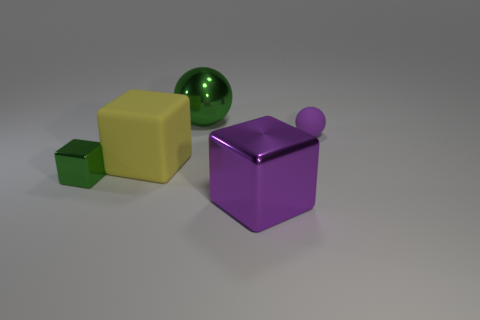Add 4 gray cylinders. How many objects exist? 9 Subtract all spheres. How many objects are left? 3 Subtract all small green things. Subtract all large spheres. How many objects are left? 3 Add 3 small things. How many small things are left? 5 Add 1 big cyan rubber objects. How many big cyan rubber objects exist? 1 Subtract 0 gray blocks. How many objects are left? 5 